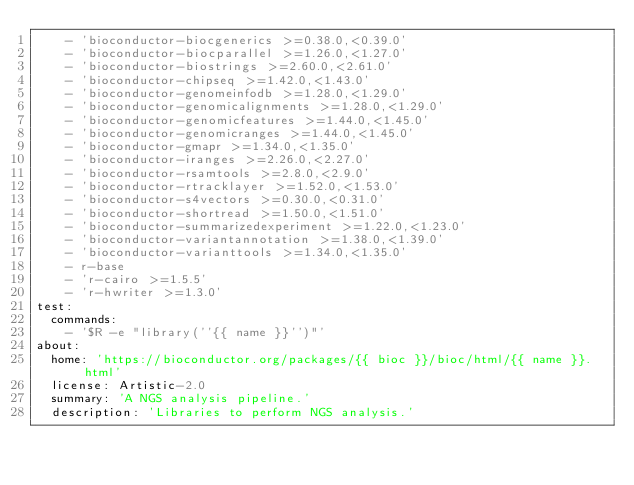<code> <loc_0><loc_0><loc_500><loc_500><_YAML_>    - 'bioconductor-biocgenerics >=0.38.0,<0.39.0'
    - 'bioconductor-biocparallel >=1.26.0,<1.27.0'
    - 'bioconductor-biostrings >=2.60.0,<2.61.0'
    - 'bioconductor-chipseq >=1.42.0,<1.43.0'
    - 'bioconductor-genomeinfodb >=1.28.0,<1.29.0'
    - 'bioconductor-genomicalignments >=1.28.0,<1.29.0'
    - 'bioconductor-genomicfeatures >=1.44.0,<1.45.0'
    - 'bioconductor-genomicranges >=1.44.0,<1.45.0'
    - 'bioconductor-gmapr >=1.34.0,<1.35.0'
    - 'bioconductor-iranges >=2.26.0,<2.27.0'
    - 'bioconductor-rsamtools >=2.8.0,<2.9.0'
    - 'bioconductor-rtracklayer >=1.52.0,<1.53.0'
    - 'bioconductor-s4vectors >=0.30.0,<0.31.0'
    - 'bioconductor-shortread >=1.50.0,<1.51.0'
    - 'bioconductor-summarizedexperiment >=1.22.0,<1.23.0'
    - 'bioconductor-variantannotation >=1.38.0,<1.39.0'
    - 'bioconductor-varianttools >=1.34.0,<1.35.0'
    - r-base
    - 'r-cairo >=1.5.5'
    - 'r-hwriter >=1.3.0'
test:
  commands:
    - '$R -e "library(''{{ name }}'')"'
about:
  home: 'https://bioconductor.org/packages/{{ bioc }}/bioc/html/{{ name }}.html'
  license: Artistic-2.0
  summary: 'A NGS analysis pipeline.'
  description: 'Libraries to perform NGS analysis.'

</code> 